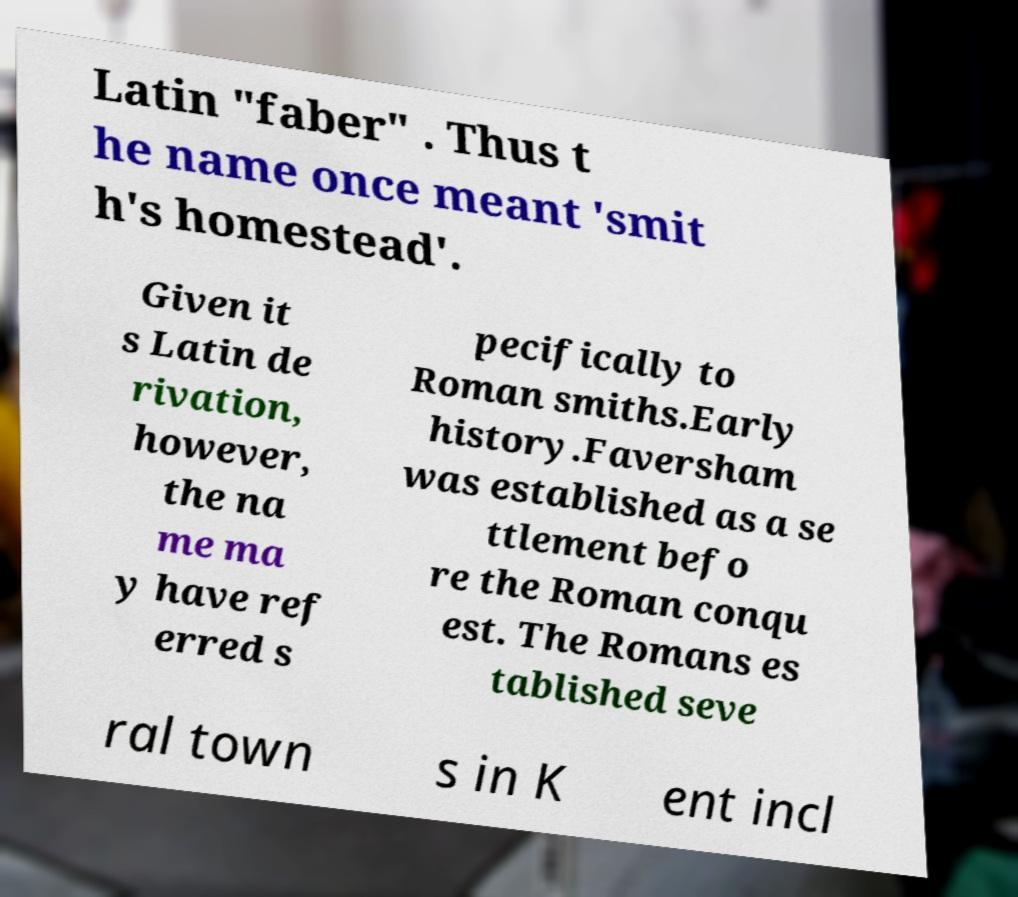Can you read and provide the text displayed in the image?This photo seems to have some interesting text. Can you extract and type it out for me? Latin "faber" . Thus t he name once meant 'smit h's homestead'. Given it s Latin de rivation, however, the na me ma y have ref erred s pecifically to Roman smiths.Early history.Faversham was established as a se ttlement befo re the Roman conqu est. The Romans es tablished seve ral town s in K ent incl 